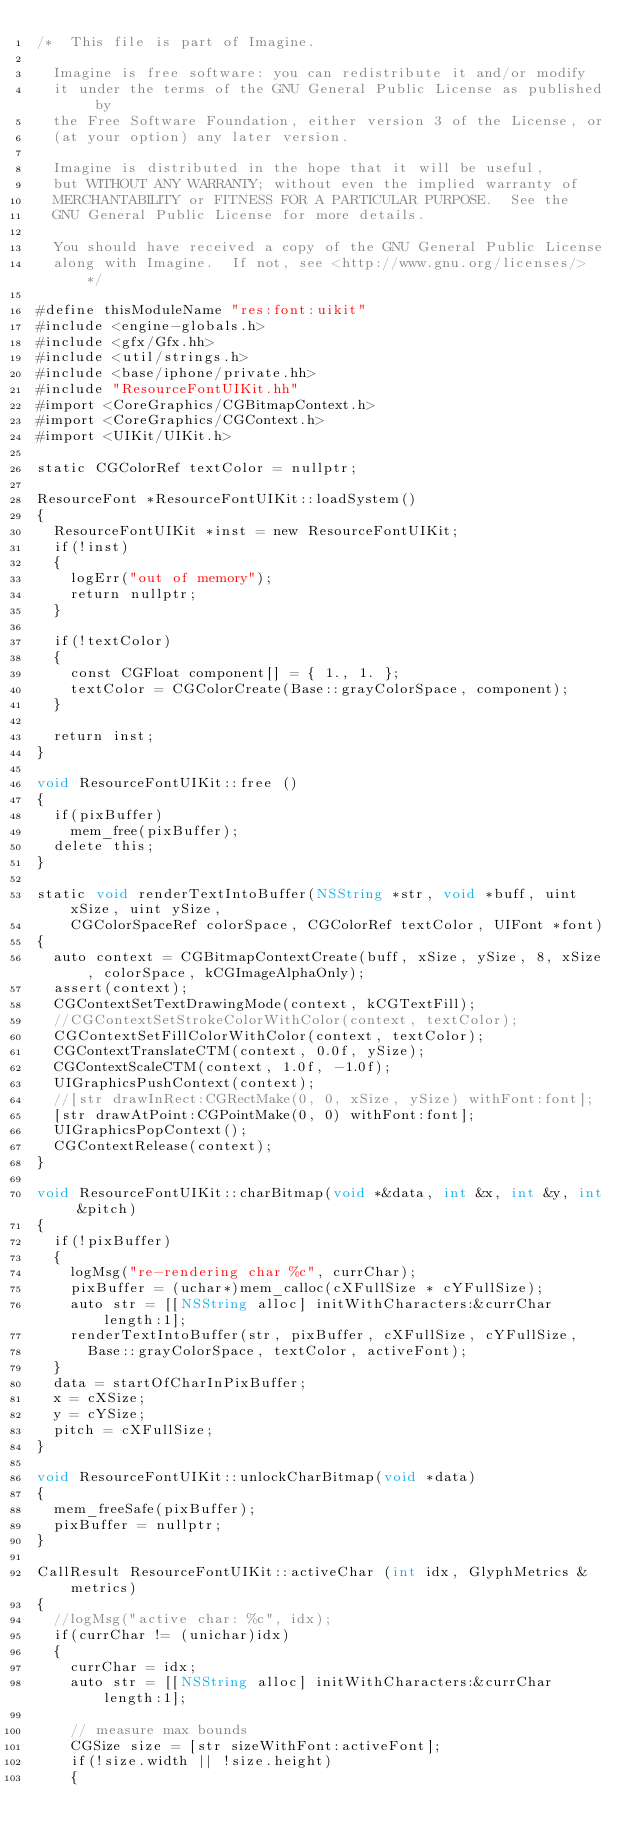Convert code to text. <code><loc_0><loc_0><loc_500><loc_500><_ObjectiveC_>/*  This file is part of Imagine.

	Imagine is free software: you can redistribute it and/or modify
	it under the terms of the GNU General Public License as published by
	the Free Software Foundation, either version 3 of the License, or
	(at your option) any later version.

	Imagine is distributed in the hope that it will be useful,
	but WITHOUT ANY WARRANTY; without even the implied warranty of
	MERCHANTABILITY or FITNESS FOR A PARTICULAR PURPOSE.  See the
	GNU General Public License for more details.

	You should have received a copy of the GNU General Public License
	along with Imagine.  If not, see <http://www.gnu.org/licenses/> */

#define thisModuleName "res:font:uikit"
#include <engine-globals.h>
#include <gfx/Gfx.hh>
#include <util/strings.h>
#include <base/iphone/private.hh>
#include "ResourceFontUIKit.hh"
#import <CoreGraphics/CGBitmapContext.h>
#import <CoreGraphics/CGContext.h>
#import <UIKit/UIKit.h>

static CGColorRef textColor = nullptr;

ResourceFont *ResourceFontUIKit::loadSystem()
{
	ResourceFontUIKit *inst = new ResourceFontUIKit;
	if(!inst)
	{
		logErr("out of memory");
		return nullptr;
	}
	
	if(!textColor)
	{
		const CGFloat component[] = { 1., 1. };
		textColor = CGColorCreate(Base::grayColorSpace, component);
	}

	return inst;
}

void ResourceFontUIKit::free ()
{
	if(pixBuffer)
		mem_free(pixBuffer);
	delete this;
}

static void renderTextIntoBuffer(NSString *str, void *buff, uint xSize, uint ySize,
		CGColorSpaceRef colorSpace, CGColorRef textColor, UIFont *font)
{
	auto context = CGBitmapContextCreate(buff, xSize, ySize, 8, xSize, colorSpace, kCGImageAlphaOnly);
	assert(context);
	CGContextSetTextDrawingMode(context, kCGTextFill);
	//CGContextSetStrokeColorWithColor(context, textColor);
	CGContextSetFillColorWithColor(context, textColor);
	CGContextTranslateCTM(context, 0.0f, ySize);
	CGContextScaleCTM(context, 1.0f, -1.0f);
	UIGraphicsPushContext(context);
	//[str drawInRect:CGRectMake(0, 0, xSize, ySize) withFont:font];
	[str drawAtPoint:CGPointMake(0, 0) withFont:font];
	UIGraphicsPopContext();
	CGContextRelease(context);
}

void ResourceFontUIKit::charBitmap(void *&data, int &x, int &y, int &pitch)
{
	if(!pixBuffer)
	{
		logMsg("re-rendering char %c", currChar);
		pixBuffer = (uchar*)mem_calloc(cXFullSize * cYFullSize);
		auto str = [[NSString alloc] initWithCharacters:&currChar length:1];
		renderTextIntoBuffer(str, pixBuffer, cXFullSize, cYFullSize,
			Base::grayColorSpace, textColor, activeFont);
	}
	data = startOfCharInPixBuffer;
	x = cXSize;
	y = cYSize;
	pitch = cXFullSize;
}

void ResourceFontUIKit::unlockCharBitmap(void *data)
{
	mem_freeSafe(pixBuffer);
	pixBuffer = nullptr;
}

CallResult ResourceFontUIKit::activeChar (int idx, GlyphMetrics &metrics)
{
	//logMsg("active char: %c", idx);
	if(currChar != (unichar)idx)
	{
		currChar = idx;
		auto str = [[NSString alloc] initWithCharacters:&currChar length:1];
		
		// measure max bounds
		CGSize size = [str sizeWithFont:activeFont];
		if(!size.width || !size.height)
		{</code> 